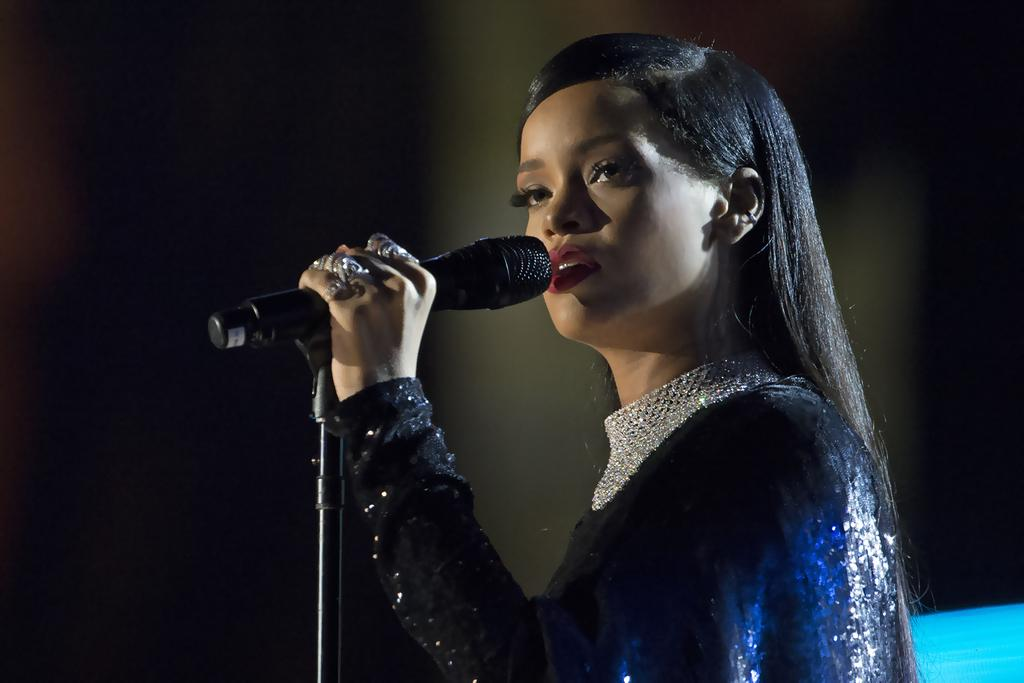What is the main subject of the image? The main subject of the image is a woman. What is the woman holding in the image? The woman is holding a mic. Can you describe the background of the image? The background of the image appears dark. What type of heat can be felt coming from the seashore in the image? There is no seashore present in the image, so it is not possible to determine what type of heat might be felt. 